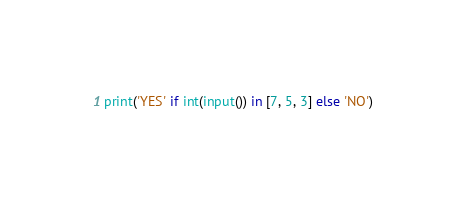Convert code to text. <code><loc_0><loc_0><loc_500><loc_500><_Python_>print('YES' if int(input()) in [7, 5, 3] else 'NO')
</code> 